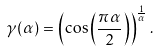<formula> <loc_0><loc_0><loc_500><loc_500>\gamma ( \alpha ) = \left ( \cos \left ( \frac { \pi \alpha } { 2 } \right ) \right ) ^ { \frac { 1 } { \alpha } } .</formula> 